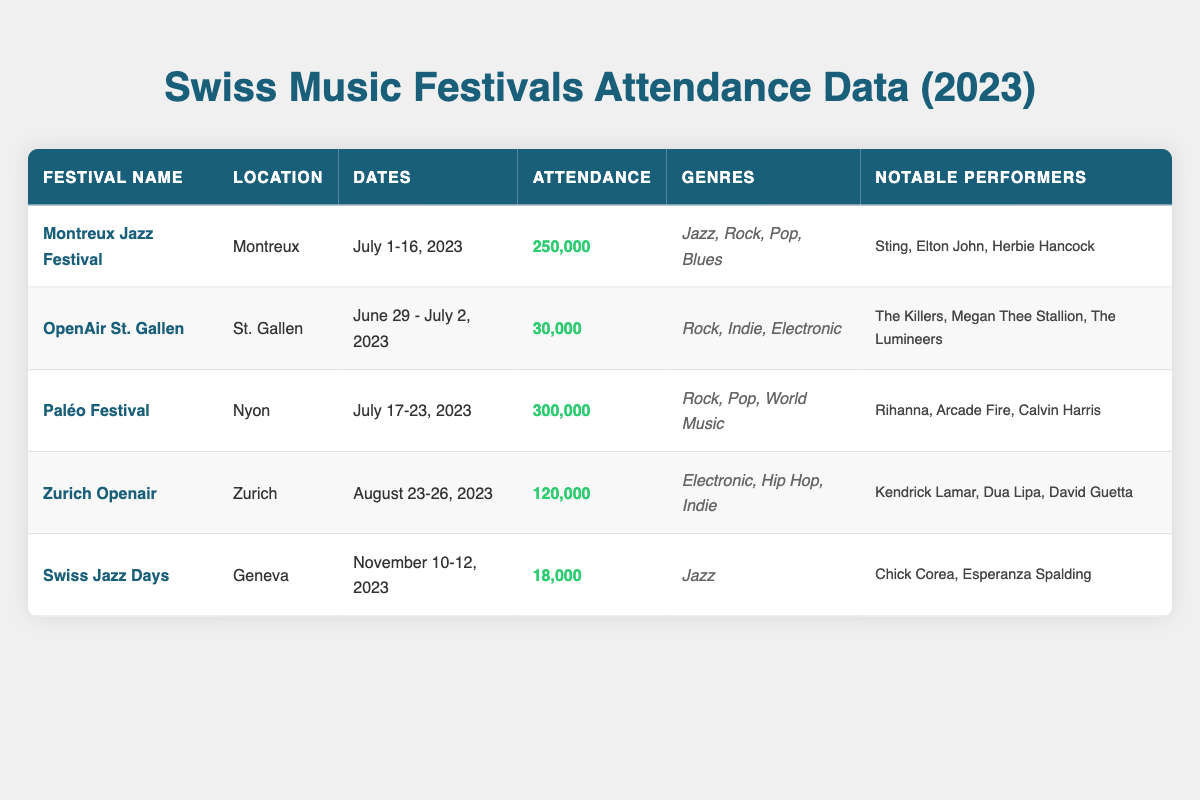What is the attendance for the Montreux Jazz Festival? From the table, under the "Attendance" column for the Montreux Jazz Festival, the value is 250,000.
Answer: 250,000 Which festival has the highest attendance? In the table, comparing the attendance values for all festivals, the Paléo Festival shows the highest attendance with 300,000.
Answer: Paléo Festival How many genres are represented at the Zurich Openair festival? Looking at the Zurich Openair, it has three genres listed: Electronic, Hip Hop, and Indie. So, the total number of genres represented is 3.
Answer: 3 What is the total attendance for all festivals listed in the table? We sum the attendance figures from each festival: 250,000 (Montreux) + 30,000 (OpenAir St. Gallen) + 300,000 (Paléo) + 120,000 (Zurich Openair) + 18,000 (Swiss Jazz Days) = 718,000.
Answer: 718,000 Did the OpenAir St. Gallen feature Jazz artists? The genres listed for the OpenAir St. Gallen festival are Rock, Indie, and Electronic. There is no mention of Jazz, indicating that Jazz artists did not perform.
Answer: No Which month has the most festivals occurring based on the table data? The table shows festivals in June (OpenAir St. Gallen), July (Montreux Jazz Festival, Paléo Festival), and August (Zurich Openair). Therefore, July has the most with two festivals, and June and August have one each.
Answer: July Are there any festivals that focus solely on Jazz? Only the Swiss Jazz Days festival lists Jazz as its sole genre.
Answer: Yes Who were notable performers at the Paléo Festival? According to the table, notable performers at the Paléo Festival included Rihanna, Arcade Fire, and Calvin Harris.
Answer: Rihanna, Arcade Fire, Calvin Harris 